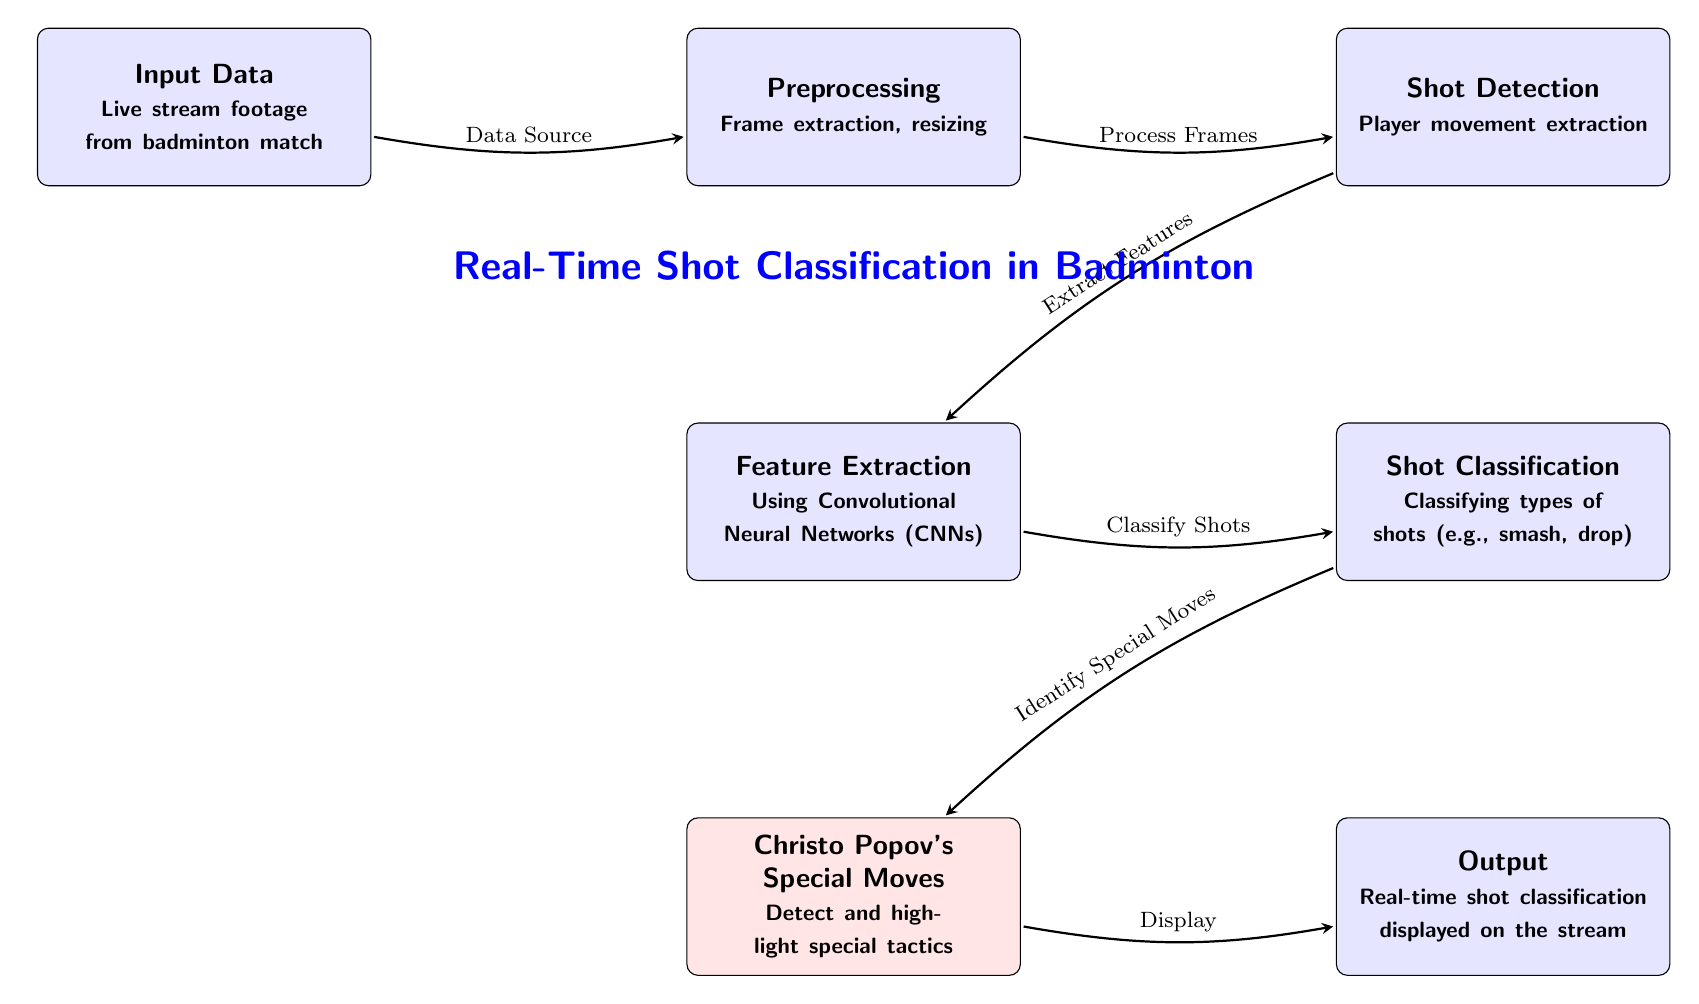What is the first step in the process? The first step is labeled as "Input Data," which indicates that the live stream footage from the badminton match is the starting point for the process.
Answer: Input Data How many nodes are there in the diagram? The diagram contains seven nodes, which are the components involved in the real-time shot classification process.
Answer: 7 What type of data is used as input? The input data is described as live stream footage from a badminton match, indicating real-time video as the source of information.
Answer: Live stream footage from badminton match What is the purpose of the "Shot Detection" node? The purpose of the "Shot Detection" node is to extract player movement, which is essential for identifying the specifics of the shots being played.
Answer: Player movement extraction What follows immediately after "Feature Extraction"? The node that follows immediately after "Feature Extraction" is "Shot Classification," which involves classifying the types of shots detected from the feature extraction process.
Answer: Shot Classification What is highlighted in the "Christo Popov's Special Moves" node? This node focuses on detecting and highlighting special tactics used by Christo Popov during matches, indicating a specialized classification of certain moves.
Answer: Detect and highlight special tactics How is the output of the classification displayed? The output is displayed in real-time on the stream, showing the results of the shot classification dynamically as the match progresses.
Answer: Real-time shot classification displayed on the stream How do the "Preprocessing" and "Shot Detection" nodes relate? The "Preprocessing" node processes frames extracted from the live footage, and subsequently, the "Shot Detection" node uses these processed frames to identify and extract player movements.
Answer: Data flow from Preprocessing to Shot Detection What step is necessary before shot classification occurs? "Feature Extraction" is the necessary step that must occur before shot classification can take place, as it prepares the extracted information for accurate classification.
Answer: Feature Extraction 